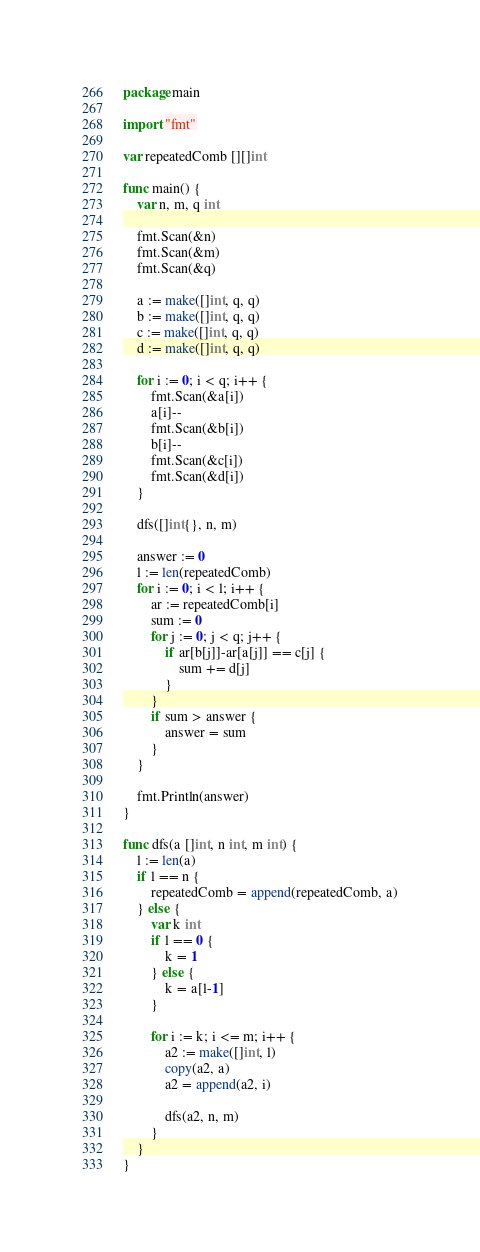<code> <loc_0><loc_0><loc_500><loc_500><_Go_>package main

import "fmt"

var repeatedComb [][]int

func main() {
	var n, m, q int

	fmt.Scan(&n)
	fmt.Scan(&m)
	fmt.Scan(&q)

	a := make([]int, q, q)
	b := make([]int, q, q)
	c := make([]int, q, q)
	d := make([]int, q, q)

	for i := 0; i < q; i++ {
		fmt.Scan(&a[i])
		a[i]--
		fmt.Scan(&b[i])
		b[i]--
		fmt.Scan(&c[i])
		fmt.Scan(&d[i])
	}

	dfs([]int{}, n, m)

	answer := 0
	l := len(repeatedComb)
	for i := 0; i < l; i++ {
		ar := repeatedComb[i]
		sum := 0
		for j := 0; j < q; j++ {
			if ar[b[j]]-ar[a[j]] == c[j] {
				sum += d[j]
			}
		}
		if sum > answer {
			answer = sum
		}
	}

	fmt.Println(answer)
}

func dfs(a []int, n int, m int) {
	l := len(a)
	if l == n {
		repeatedComb = append(repeatedComb, a)
	} else {
		var k int
		if l == 0 {
			k = 1
		} else {
			k = a[l-1]
		}

		for i := k; i <= m; i++ {
			a2 := make([]int, l)
			copy(a2, a)
			a2 = append(a2, i)

			dfs(a2, n, m)
		}
	}
}
</code> 